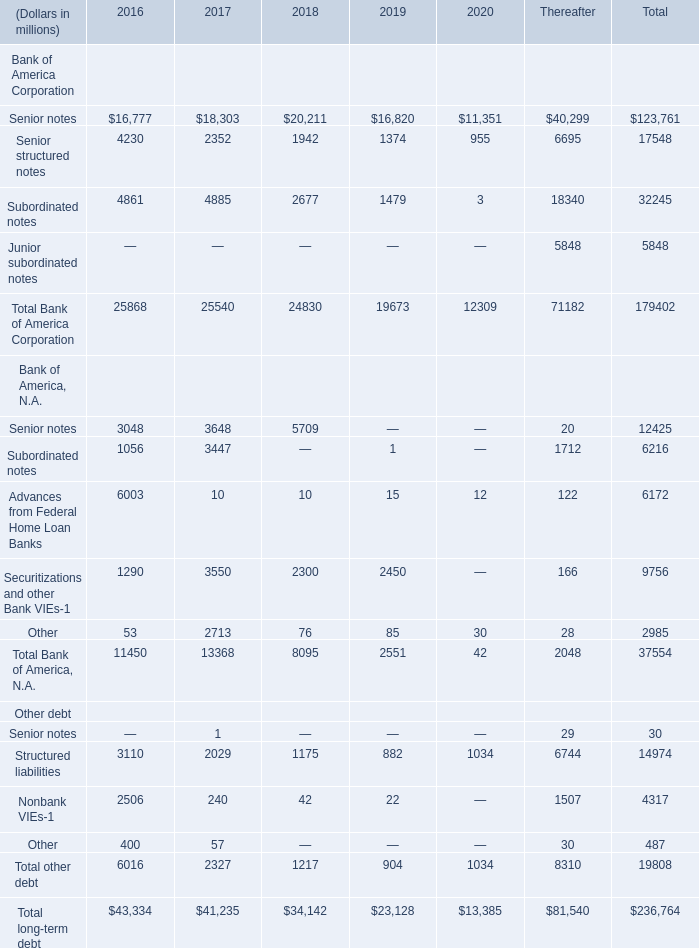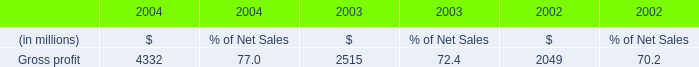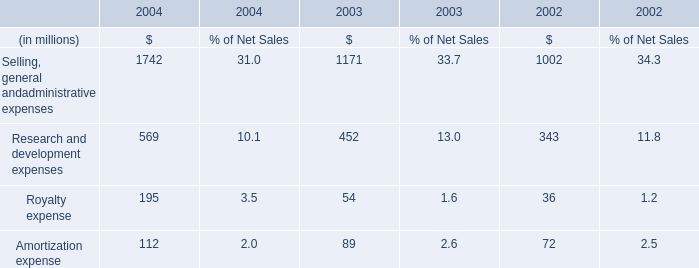In the year with the most Subordinated notes of Bank of America Corporation in table 0, what is the growth rate of Senior notes of Bank of America Corporation? 
Computations: ((18303 - 16777) / 16777)
Answer: 0.09096. 